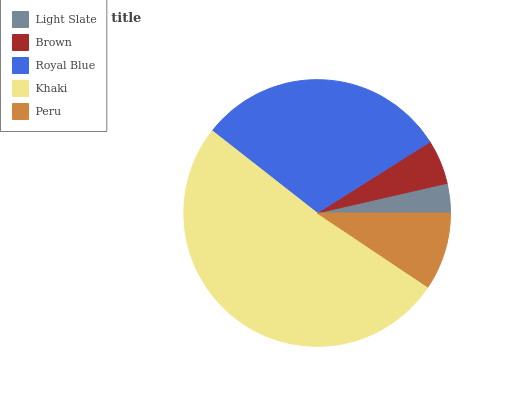Is Light Slate the minimum?
Answer yes or no. Yes. Is Khaki the maximum?
Answer yes or no. Yes. Is Brown the minimum?
Answer yes or no. No. Is Brown the maximum?
Answer yes or no. No. Is Brown greater than Light Slate?
Answer yes or no. Yes. Is Light Slate less than Brown?
Answer yes or no. Yes. Is Light Slate greater than Brown?
Answer yes or no. No. Is Brown less than Light Slate?
Answer yes or no. No. Is Peru the high median?
Answer yes or no. Yes. Is Peru the low median?
Answer yes or no. Yes. Is Light Slate the high median?
Answer yes or no. No. Is Royal Blue the low median?
Answer yes or no. No. 